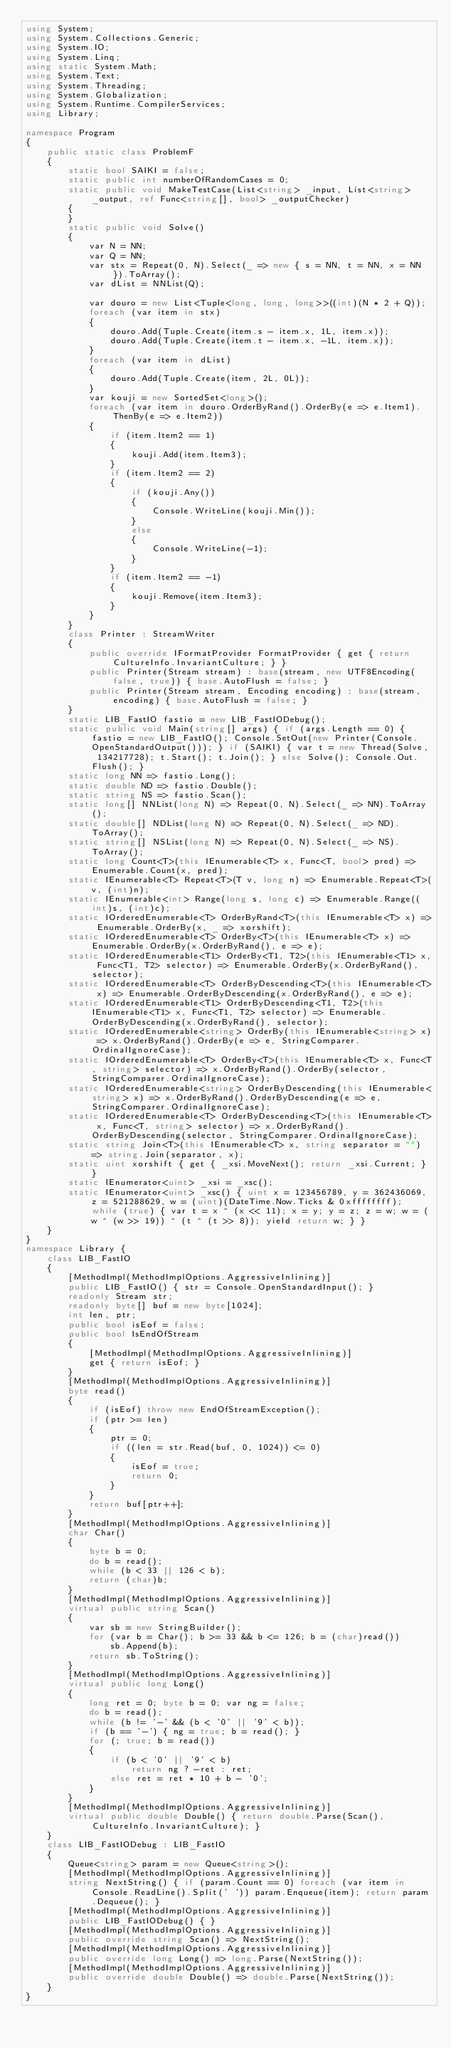<code> <loc_0><loc_0><loc_500><loc_500><_C#_>using System;
using System.Collections.Generic;
using System.IO;
using System.Linq;
using static System.Math;
using System.Text;
using System.Threading;
using System.Globalization;
using System.Runtime.CompilerServices;
using Library;

namespace Program
{
    public static class ProblemF
    {
        static bool SAIKI = false;
        static public int numberOfRandomCases = 0;
        static public void MakeTestCase(List<string> _input, List<string> _output, ref Func<string[], bool> _outputChecker)
        {
        }
        static public void Solve()
        {
            var N = NN;
            var Q = NN;
            var stx = Repeat(0, N).Select(_ => new { s = NN, t = NN, x = NN }).ToArray();
            var dList = NNList(Q);

            var douro = new List<Tuple<long, long, long>>((int)(N * 2 + Q));
            foreach (var item in stx)
            {
                douro.Add(Tuple.Create(item.s - item.x, 1L, item.x));
                douro.Add(Tuple.Create(item.t - item.x, -1L, item.x));
            }
            foreach (var item in dList)
            {
                douro.Add(Tuple.Create(item, 2L, 0L));
            }
            var kouji = new SortedSet<long>();
            foreach (var item in douro.OrderByRand().OrderBy(e => e.Item1).ThenBy(e => e.Item2))
            {
                if (item.Item2 == 1)
                {
                    kouji.Add(item.Item3);
                }
                if (item.Item2 == 2)
                {
                    if (kouji.Any())
                    {
                        Console.WriteLine(kouji.Min());
                    }
                    else
                    {
                        Console.WriteLine(-1);
                    }
                }
                if (item.Item2 == -1)
                {
                    kouji.Remove(item.Item3);
                }
            }
        }
        class Printer : StreamWriter
        {
            public override IFormatProvider FormatProvider { get { return CultureInfo.InvariantCulture; } }
            public Printer(Stream stream) : base(stream, new UTF8Encoding(false, true)) { base.AutoFlush = false; }
            public Printer(Stream stream, Encoding encoding) : base(stream, encoding) { base.AutoFlush = false; }
        }
        static LIB_FastIO fastio = new LIB_FastIODebug();
        static public void Main(string[] args) { if (args.Length == 0) { fastio = new LIB_FastIO(); Console.SetOut(new Printer(Console.OpenStandardOutput())); } if (SAIKI) { var t = new Thread(Solve, 134217728); t.Start(); t.Join(); } else Solve(); Console.Out.Flush(); }
        static long NN => fastio.Long();
        static double ND => fastio.Double();
        static string NS => fastio.Scan();
        static long[] NNList(long N) => Repeat(0, N).Select(_ => NN).ToArray();
        static double[] NDList(long N) => Repeat(0, N).Select(_ => ND).ToArray();
        static string[] NSList(long N) => Repeat(0, N).Select(_ => NS).ToArray();
        static long Count<T>(this IEnumerable<T> x, Func<T, bool> pred) => Enumerable.Count(x, pred);
        static IEnumerable<T> Repeat<T>(T v, long n) => Enumerable.Repeat<T>(v, (int)n);
        static IEnumerable<int> Range(long s, long c) => Enumerable.Range((int)s, (int)c);
        static IOrderedEnumerable<T> OrderByRand<T>(this IEnumerable<T> x) => Enumerable.OrderBy(x, _ => xorshift);
        static IOrderedEnumerable<T> OrderBy<T>(this IEnumerable<T> x) => Enumerable.OrderBy(x.OrderByRand(), e => e);
        static IOrderedEnumerable<T1> OrderBy<T1, T2>(this IEnumerable<T1> x, Func<T1, T2> selector) => Enumerable.OrderBy(x.OrderByRand(), selector);
        static IOrderedEnumerable<T> OrderByDescending<T>(this IEnumerable<T> x) => Enumerable.OrderByDescending(x.OrderByRand(), e => e);
        static IOrderedEnumerable<T1> OrderByDescending<T1, T2>(this IEnumerable<T1> x, Func<T1, T2> selector) => Enumerable.OrderByDescending(x.OrderByRand(), selector);
        static IOrderedEnumerable<string> OrderBy(this IEnumerable<string> x) => x.OrderByRand().OrderBy(e => e, StringComparer.OrdinalIgnoreCase);
        static IOrderedEnumerable<T> OrderBy<T>(this IEnumerable<T> x, Func<T, string> selector) => x.OrderByRand().OrderBy(selector, StringComparer.OrdinalIgnoreCase);
        static IOrderedEnumerable<string> OrderByDescending(this IEnumerable<string> x) => x.OrderByRand().OrderByDescending(e => e, StringComparer.OrdinalIgnoreCase);
        static IOrderedEnumerable<T> OrderByDescending<T>(this IEnumerable<T> x, Func<T, string> selector) => x.OrderByRand().OrderByDescending(selector, StringComparer.OrdinalIgnoreCase);
        static string Join<T>(this IEnumerable<T> x, string separator = "") => string.Join(separator, x);
        static uint xorshift { get { _xsi.MoveNext(); return _xsi.Current; } }
        static IEnumerator<uint> _xsi = _xsc();
        static IEnumerator<uint> _xsc() { uint x = 123456789, y = 362436069, z = 521288629, w = (uint)(DateTime.Now.Ticks & 0xffffffff); while (true) { var t = x ^ (x << 11); x = y; y = z; z = w; w = (w ^ (w >> 19)) ^ (t ^ (t >> 8)); yield return w; } }
    }
}
namespace Library {
    class LIB_FastIO
    {
        [MethodImpl(MethodImplOptions.AggressiveInlining)]
        public LIB_FastIO() { str = Console.OpenStandardInput(); }
        readonly Stream str;
        readonly byte[] buf = new byte[1024];
        int len, ptr;
        public bool isEof = false;
        public bool IsEndOfStream
        {
            [MethodImpl(MethodImplOptions.AggressiveInlining)]
            get { return isEof; }
        }
        [MethodImpl(MethodImplOptions.AggressiveInlining)]
        byte read()
        {
            if (isEof) throw new EndOfStreamException();
            if (ptr >= len)
            {
                ptr = 0;
                if ((len = str.Read(buf, 0, 1024)) <= 0)
                {
                    isEof = true;
                    return 0;
                }
            }
            return buf[ptr++];
        }
        [MethodImpl(MethodImplOptions.AggressiveInlining)]
        char Char()
        {
            byte b = 0;
            do b = read();
            while (b < 33 || 126 < b);
            return (char)b;
        }
        [MethodImpl(MethodImplOptions.AggressiveInlining)]
        virtual public string Scan()
        {
            var sb = new StringBuilder();
            for (var b = Char(); b >= 33 && b <= 126; b = (char)read())
                sb.Append(b);
            return sb.ToString();
        }
        [MethodImpl(MethodImplOptions.AggressiveInlining)]
        virtual public long Long()
        {
            long ret = 0; byte b = 0; var ng = false;
            do b = read();
            while (b != '-' && (b < '0' || '9' < b));
            if (b == '-') { ng = true; b = read(); }
            for (; true; b = read())
            {
                if (b < '0' || '9' < b)
                    return ng ? -ret : ret;
                else ret = ret * 10 + b - '0';
            }
        }
        [MethodImpl(MethodImplOptions.AggressiveInlining)]
        virtual public double Double() { return double.Parse(Scan(), CultureInfo.InvariantCulture); }
    }
    class LIB_FastIODebug : LIB_FastIO
    {
        Queue<string> param = new Queue<string>();
        [MethodImpl(MethodImplOptions.AggressiveInlining)]
        string NextString() { if (param.Count == 0) foreach (var item in Console.ReadLine().Split(' ')) param.Enqueue(item); return param.Dequeue(); }
        [MethodImpl(MethodImplOptions.AggressiveInlining)]
        public LIB_FastIODebug() { }
        [MethodImpl(MethodImplOptions.AggressiveInlining)]
        public override string Scan() => NextString();
        [MethodImpl(MethodImplOptions.AggressiveInlining)]
        public override long Long() => long.Parse(NextString());
        [MethodImpl(MethodImplOptions.AggressiveInlining)]
        public override double Double() => double.Parse(NextString());
    }
}
</code> 